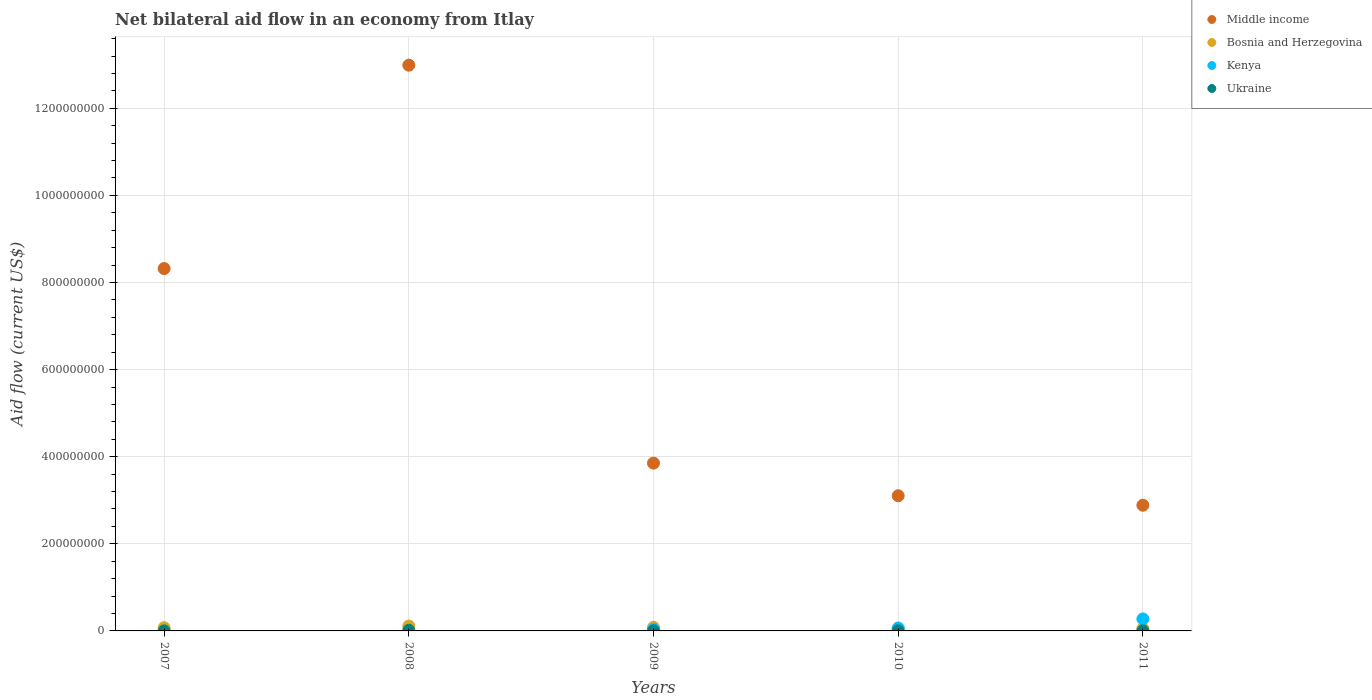Across all years, what is the maximum net bilateral aid flow in Ukraine?
Provide a short and direct response. 1.38e+06. Across all years, what is the minimum net bilateral aid flow in Middle income?
Your response must be concise. 2.89e+08. What is the total net bilateral aid flow in Middle income in the graph?
Offer a very short reply. 3.12e+09. What is the difference between the net bilateral aid flow in Middle income in 2008 and that in 2010?
Your answer should be very brief. 9.89e+08. What is the difference between the net bilateral aid flow in Kenya in 2011 and the net bilateral aid flow in Ukraine in 2007?
Offer a very short reply. 2.74e+07. What is the average net bilateral aid flow in Kenya per year?
Ensure brevity in your answer.  7.44e+06. In the year 2009, what is the difference between the net bilateral aid flow in Kenya and net bilateral aid flow in Ukraine?
Give a very brief answer. 2.78e+06. In how many years, is the net bilateral aid flow in Kenya greater than 1200000000 US$?
Your answer should be compact. 0. What is the ratio of the net bilateral aid flow in Ukraine in 2007 to that in 2008?
Provide a succinct answer. 0.07. What is the difference between the highest and the second highest net bilateral aid flow in Bosnia and Herzegovina?
Give a very brief answer. 3.05e+06. What is the difference between the highest and the lowest net bilateral aid flow in Kenya?
Offer a very short reply. 2.75e+07. In how many years, is the net bilateral aid flow in Ukraine greater than the average net bilateral aid flow in Ukraine taken over all years?
Provide a succinct answer. 1. Is the sum of the net bilateral aid flow in Bosnia and Herzegovina in 2009 and 2011 greater than the maximum net bilateral aid flow in Ukraine across all years?
Provide a succinct answer. Yes. Is it the case that in every year, the sum of the net bilateral aid flow in Ukraine and net bilateral aid flow in Kenya  is greater than the net bilateral aid flow in Bosnia and Herzegovina?
Offer a very short reply. No. Is the net bilateral aid flow in Middle income strictly greater than the net bilateral aid flow in Kenya over the years?
Ensure brevity in your answer.  Yes. Is the net bilateral aid flow in Ukraine strictly less than the net bilateral aid flow in Kenya over the years?
Offer a very short reply. No. Does the graph contain grids?
Your answer should be compact. Yes. How many legend labels are there?
Make the answer very short. 4. How are the legend labels stacked?
Your response must be concise. Vertical. What is the title of the graph?
Offer a terse response. Net bilateral aid flow in an economy from Itlay. Does "Thailand" appear as one of the legend labels in the graph?
Give a very brief answer. No. What is the Aid flow (current US$) in Middle income in 2007?
Your response must be concise. 8.32e+08. What is the Aid flow (current US$) in Bosnia and Herzegovina in 2007?
Offer a very short reply. 7.40e+06. What is the Aid flow (current US$) in Kenya in 2007?
Provide a succinct answer. 0. What is the Aid flow (current US$) in Ukraine in 2007?
Keep it short and to the point. 1.00e+05. What is the Aid flow (current US$) in Middle income in 2008?
Your answer should be very brief. 1.30e+09. What is the Aid flow (current US$) of Bosnia and Herzegovina in 2008?
Give a very brief answer. 1.12e+07. What is the Aid flow (current US$) in Kenya in 2008?
Make the answer very short. 0. What is the Aid flow (current US$) in Ukraine in 2008?
Your answer should be compact. 1.38e+06. What is the Aid flow (current US$) in Middle income in 2009?
Your response must be concise. 3.85e+08. What is the Aid flow (current US$) of Bosnia and Herzegovina in 2009?
Make the answer very short. 8.16e+06. What is the Aid flow (current US$) in Kenya in 2009?
Your answer should be very brief. 2.96e+06. What is the Aid flow (current US$) of Middle income in 2010?
Give a very brief answer. 3.10e+08. What is the Aid flow (current US$) of Bosnia and Herzegovina in 2010?
Offer a very short reply. 4.92e+06. What is the Aid flow (current US$) of Kenya in 2010?
Keep it short and to the point. 6.69e+06. What is the Aid flow (current US$) of Middle income in 2011?
Keep it short and to the point. 2.89e+08. What is the Aid flow (current US$) of Bosnia and Herzegovina in 2011?
Offer a very short reply. 5.19e+06. What is the Aid flow (current US$) in Kenya in 2011?
Provide a succinct answer. 2.75e+07. Across all years, what is the maximum Aid flow (current US$) in Middle income?
Your answer should be very brief. 1.30e+09. Across all years, what is the maximum Aid flow (current US$) of Bosnia and Herzegovina?
Your response must be concise. 1.12e+07. Across all years, what is the maximum Aid flow (current US$) of Kenya?
Give a very brief answer. 2.75e+07. Across all years, what is the maximum Aid flow (current US$) in Ukraine?
Provide a short and direct response. 1.38e+06. Across all years, what is the minimum Aid flow (current US$) of Middle income?
Keep it short and to the point. 2.89e+08. Across all years, what is the minimum Aid flow (current US$) in Bosnia and Herzegovina?
Provide a short and direct response. 4.92e+06. Across all years, what is the minimum Aid flow (current US$) of Kenya?
Give a very brief answer. 0. What is the total Aid flow (current US$) of Middle income in the graph?
Your answer should be compact. 3.12e+09. What is the total Aid flow (current US$) of Bosnia and Herzegovina in the graph?
Your answer should be compact. 3.69e+07. What is the total Aid flow (current US$) of Kenya in the graph?
Offer a terse response. 3.72e+07. What is the total Aid flow (current US$) in Ukraine in the graph?
Provide a succinct answer. 2.26e+06. What is the difference between the Aid flow (current US$) of Middle income in 2007 and that in 2008?
Your answer should be compact. -4.67e+08. What is the difference between the Aid flow (current US$) in Bosnia and Herzegovina in 2007 and that in 2008?
Keep it short and to the point. -3.81e+06. What is the difference between the Aid flow (current US$) of Ukraine in 2007 and that in 2008?
Provide a succinct answer. -1.28e+06. What is the difference between the Aid flow (current US$) in Middle income in 2007 and that in 2009?
Provide a succinct answer. 4.47e+08. What is the difference between the Aid flow (current US$) in Bosnia and Herzegovina in 2007 and that in 2009?
Keep it short and to the point. -7.60e+05. What is the difference between the Aid flow (current US$) in Middle income in 2007 and that in 2010?
Offer a terse response. 5.22e+08. What is the difference between the Aid flow (current US$) in Bosnia and Herzegovina in 2007 and that in 2010?
Your response must be concise. 2.48e+06. What is the difference between the Aid flow (current US$) of Ukraine in 2007 and that in 2010?
Provide a short and direct response. -1.80e+05. What is the difference between the Aid flow (current US$) in Middle income in 2007 and that in 2011?
Ensure brevity in your answer.  5.43e+08. What is the difference between the Aid flow (current US$) of Bosnia and Herzegovina in 2007 and that in 2011?
Your answer should be very brief. 2.21e+06. What is the difference between the Aid flow (current US$) of Ukraine in 2007 and that in 2011?
Make the answer very short. -2.20e+05. What is the difference between the Aid flow (current US$) in Middle income in 2008 and that in 2009?
Your response must be concise. 9.14e+08. What is the difference between the Aid flow (current US$) of Bosnia and Herzegovina in 2008 and that in 2009?
Offer a terse response. 3.05e+06. What is the difference between the Aid flow (current US$) in Ukraine in 2008 and that in 2009?
Provide a short and direct response. 1.20e+06. What is the difference between the Aid flow (current US$) in Middle income in 2008 and that in 2010?
Your answer should be compact. 9.89e+08. What is the difference between the Aid flow (current US$) in Bosnia and Herzegovina in 2008 and that in 2010?
Offer a very short reply. 6.29e+06. What is the difference between the Aid flow (current US$) in Ukraine in 2008 and that in 2010?
Ensure brevity in your answer.  1.10e+06. What is the difference between the Aid flow (current US$) of Middle income in 2008 and that in 2011?
Your answer should be compact. 1.01e+09. What is the difference between the Aid flow (current US$) in Bosnia and Herzegovina in 2008 and that in 2011?
Ensure brevity in your answer.  6.02e+06. What is the difference between the Aid flow (current US$) of Ukraine in 2008 and that in 2011?
Make the answer very short. 1.06e+06. What is the difference between the Aid flow (current US$) in Middle income in 2009 and that in 2010?
Ensure brevity in your answer.  7.49e+07. What is the difference between the Aid flow (current US$) in Bosnia and Herzegovina in 2009 and that in 2010?
Offer a very short reply. 3.24e+06. What is the difference between the Aid flow (current US$) of Kenya in 2009 and that in 2010?
Provide a short and direct response. -3.73e+06. What is the difference between the Aid flow (current US$) of Ukraine in 2009 and that in 2010?
Provide a short and direct response. -1.00e+05. What is the difference between the Aid flow (current US$) of Middle income in 2009 and that in 2011?
Provide a short and direct response. 9.66e+07. What is the difference between the Aid flow (current US$) of Bosnia and Herzegovina in 2009 and that in 2011?
Ensure brevity in your answer.  2.97e+06. What is the difference between the Aid flow (current US$) in Kenya in 2009 and that in 2011?
Provide a succinct answer. -2.46e+07. What is the difference between the Aid flow (current US$) in Middle income in 2010 and that in 2011?
Keep it short and to the point. 2.17e+07. What is the difference between the Aid flow (current US$) of Kenya in 2010 and that in 2011?
Make the answer very short. -2.08e+07. What is the difference between the Aid flow (current US$) in Ukraine in 2010 and that in 2011?
Keep it short and to the point. -4.00e+04. What is the difference between the Aid flow (current US$) in Middle income in 2007 and the Aid flow (current US$) in Bosnia and Herzegovina in 2008?
Give a very brief answer. 8.21e+08. What is the difference between the Aid flow (current US$) in Middle income in 2007 and the Aid flow (current US$) in Ukraine in 2008?
Your answer should be compact. 8.31e+08. What is the difference between the Aid flow (current US$) in Bosnia and Herzegovina in 2007 and the Aid flow (current US$) in Ukraine in 2008?
Your answer should be very brief. 6.02e+06. What is the difference between the Aid flow (current US$) in Middle income in 2007 and the Aid flow (current US$) in Bosnia and Herzegovina in 2009?
Your response must be concise. 8.24e+08. What is the difference between the Aid flow (current US$) of Middle income in 2007 and the Aid flow (current US$) of Kenya in 2009?
Make the answer very short. 8.29e+08. What is the difference between the Aid flow (current US$) of Middle income in 2007 and the Aid flow (current US$) of Ukraine in 2009?
Provide a succinct answer. 8.32e+08. What is the difference between the Aid flow (current US$) of Bosnia and Herzegovina in 2007 and the Aid flow (current US$) of Kenya in 2009?
Your answer should be very brief. 4.44e+06. What is the difference between the Aid flow (current US$) in Bosnia and Herzegovina in 2007 and the Aid flow (current US$) in Ukraine in 2009?
Provide a short and direct response. 7.22e+06. What is the difference between the Aid flow (current US$) in Middle income in 2007 and the Aid flow (current US$) in Bosnia and Herzegovina in 2010?
Offer a terse response. 8.27e+08. What is the difference between the Aid flow (current US$) of Middle income in 2007 and the Aid flow (current US$) of Kenya in 2010?
Provide a succinct answer. 8.25e+08. What is the difference between the Aid flow (current US$) in Middle income in 2007 and the Aid flow (current US$) in Ukraine in 2010?
Your response must be concise. 8.32e+08. What is the difference between the Aid flow (current US$) of Bosnia and Herzegovina in 2007 and the Aid flow (current US$) of Kenya in 2010?
Offer a terse response. 7.10e+05. What is the difference between the Aid flow (current US$) in Bosnia and Herzegovina in 2007 and the Aid flow (current US$) in Ukraine in 2010?
Provide a short and direct response. 7.12e+06. What is the difference between the Aid flow (current US$) in Middle income in 2007 and the Aid flow (current US$) in Bosnia and Herzegovina in 2011?
Ensure brevity in your answer.  8.27e+08. What is the difference between the Aid flow (current US$) in Middle income in 2007 and the Aid flow (current US$) in Kenya in 2011?
Your answer should be very brief. 8.04e+08. What is the difference between the Aid flow (current US$) of Middle income in 2007 and the Aid flow (current US$) of Ukraine in 2011?
Ensure brevity in your answer.  8.32e+08. What is the difference between the Aid flow (current US$) in Bosnia and Herzegovina in 2007 and the Aid flow (current US$) in Kenya in 2011?
Offer a terse response. -2.01e+07. What is the difference between the Aid flow (current US$) in Bosnia and Herzegovina in 2007 and the Aid flow (current US$) in Ukraine in 2011?
Offer a very short reply. 7.08e+06. What is the difference between the Aid flow (current US$) of Middle income in 2008 and the Aid flow (current US$) of Bosnia and Herzegovina in 2009?
Offer a very short reply. 1.29e+09. What is the difference between the Aid flow (current US$) in Middle income in 2008 and the Aid flow (current US$) in Kenya in 2009?
Give a very brief answer. 1.30e+09. What is the difference between the Aid flow (current US$) of Middle income in 2008 and the Aid flow (current US$) of Ukraine in 2009?
Offer a very short reply. 1.30e+09. What is the difference between the Aid flow (current US$) in Bosnia and Herzegovina in 2008 and the Aid flow (current US$) in Kenya in 2009?
Ensure brevity in your answer.  8.25e+06. What is the difference between the Aid flow (current US$) of Bosnia and Herzegovina in 2008 and the Aid flow (current US$) of Ukraine in 2009?
Give a very brief answer. 1.10e+07. What is the difference between the Aid flow (current US$) of Middle income in 2008 and the Aid flow (current US$) of Bosnia and Herzegovina in 2010?
Your answer should be compact. 1.29e+09. What is the difference between the Aid flow (current US$) in Middle income in 2008 and the Aid flow (current US$) in Kenya in 2010?
Provide a succinct answer. 1.29e+09. What is the difference between the Aid flow (current US$) in Middle income in 2008 and the Aid flow (current US$) in Ukraine in 2010?
Ensure brevity in your answer.  1.30e+09. What is the difference between the Aid flow (current US$) of Bosnia and Herzegovina in 2008 and the Aid flow (current US$) of Kenya in 2010?
Your response must be concise. 4.52e+06. What is the difference between the Aid flow (current US$) in Bosnia and Herzegovina in 2008 and the Aid flow (current US$) in Ukraine in 2010?
Make the answer very short. 1.09e+07. What is the difference between the Aid flow (current US$) of Middle income in 2008 and the Aid flow (current US$) of Bosnia and Herzegovina in 2011?
Your answer should be compact. 1.29e+09. What is the difference between the Aid flow (current US$) in Middle income in 2008 and the Aid flow (current US$) in Kenya in 2011?
Provide a succinct answer. 1.27e+09. What is the difference between the Aid flow (current US$) in Middle income in 2008 and the Aid flow (current US$) in Ukraine in 2011?
Your response must be concise. 1.30e+09. What is the difference between the Aid flow (current US$) of Bosnia and Herzegovina in 2008 and the Aid flow (current US$) of Kenya in 2011?
Offer a very short reply. -1.63e+07. What is the difference between the Aid flow (current US$) of Bosnia and Herzegovina in 2008 and the Aid flow (current US$) of Ukraine in 2011?
Keep it short and to the point. 1.09e+07. What is the difference between the Aid flow (current US$) in Middle income in 2009 and the Aid flow (current US$) in Bosnia and Herzegovina in 2010?
Provide a short and direct response. 3.80e+08. What is the difference between the Aid flow (current US$) of Middle income in 2009 and the Aid flow (current US$) of Kenya in 2010?
Provide a succinct answer. 3.79e+08. What is the difference between the Aid flow (current US$) in Middle income in 2009 and the Aid flow (current US$) in Ukraine in 2010?
Your answer should be very brief. 3.85e+08. What is the difference between the Aid flow (current US$) of Bosnia and Herzegovina in 2009 and the Aid flow (current US$) of Kenya in 2010?
Offer a very short reply. 1.47e+06. What is the difference between the Aid flow (current US$) of Bosnia and Herzegovina in 2009 and the Aid flow (current US$) of Ukraine in 2010?
Ensure brevity in your answer.  7.88e+06. What is the difference between the Aid flow (current US$) of Kenya in 2009 and the Aid flow (current US$) of Ukraine in 2010?
Your answer should be very brief. 2.68e+06. What is the difference between the Aid flow (current US$) in Middle income in 2009 and the Aid flow (current US$) in Bosnia and Herzegovina in 2011?
Ensure brevity in your answer.  3.80e+08. What is the difference between the Aid flow (current US$) in Middle income in 2009 and the Aid flow (current US$) in Kenya in 2011?
Your answer should be very brief. 3.58e+08. What is the difference between the Aid flow (current US$) of Middle income in 2009 and the Aid flow (current US$) of Ukraine in 2011?
Ensure brevity in your answer.  3.85e+08. What is the difference between the Aid flow (current US$) of Bosnia and Herzegovina in 2009 and the Aid flow (current US$) of Kenya in 2011?
Provide a succinct answer. -1.94e+07. What is the difference between the Aid flow (current US$) of Bosnia and Herzegovina in 2009 and the Aid flow (current US$) of Ukraine in 2011?
Keep it short and to the point. 7.84e+06. What is the difference between the Aid flow (current US$) of Kenya in 2009 and the Aid flow (current US$) of Ukraine in 2011?
Your response must be concise. 2.64e+06. What is the difference between the Aid flow (current US$) in Middle income in 2010 and the Aid flow (current US$) in Bosnia and Herzegovina in 2011?
Provide a short and direct response. 3.05e+08. What is the difference between the Aid flow (current US$) of Middle income in 2010 and the Aid flow (current US$) of Kenya in 2011?
Keep it short and to the point. 2.83e+08. What is the difference between the Aid flow (current US$) in Middle income in 2010 and the Aid flow (current US$) in Ukraine in 2011?
Your answer should be very brief. 3.10e+08. What is the difference between the Aid flow (current US$) of Bosnia and Herzegovina in 2010 and the Aid flow (current US$) of Kenya in 2011?
Give a very brief answer. -2.26e+07. What is the difference between the Aid flow (current US$) of Bosnia and Herzegovina in 2010 and the Aid flow (current US$) of Ukraine in 2011?
Provide a succinct answer. 4.60e+06. What is the difference between the Aid flow (current US$) in Kenya in 2010 and the Aid flow (current US$) in Ukraine in 2011?
Give a very brief answer. 6.37e+06. What is the average Aid flow (current US$) in Middle income per year?
Offer a terse response. 6.23e+08. What is the average Aid flow (current US$) of Bosnia and Herzegovina per year?
Your answer should be compact. 7.38e+06. What is the average Aid flow (current US$) of Kenya per year?
Keep it short and to the point. 7.44e+06. What is the average Aid flow (current US$) in Ukraine per year?
Offer a terse response. 4.52e+05. In the year 2007, what is the difference between the Aid flow (current US$) in Middle income and Aid flow (current US$) in Bosnia and Herzegovina?
Your answer should be compact. 8.25e+08. In the year 2007, what is the difference between the Aid flow (current US$) in Middle income and Aid flow (current US$) in Ukraine?
Offer a very short reply. 8.32e+08. In the year 2007, what is the difference between the Aid flow (current US$) in Bosnia and Herzegovina and Aid flow (current US$) in Ukraine?
Provide a short and direct response. 7.30e+06. In the year 2008, what is the difference between the Aid flow (current US$) in Middle income and Aid flow (current US$) in Bosnia and Herzegovina?
Give a very brief answer. 1.29e+09. In the year 2008, what is the difference between the Aid flow (current US$) in Middle income and Aid flow (current US$) in Ukraine?
Offer a very short reply. 1.30e+09. In the year 2008, what is the difference between the Aid flow (current US$) in Bosnia and Herzegovina and Aid flow (current US$) in Ukraine?
Give a very brief answer. 9.83e+06. In the year 2009, what is the difference between the Aid flow (current US$) of Middle income and Aid flow (current US$) of Bosnia and Herzegovina?
Your response must be concise. 3.77e+08. In the year 2009, what is the difference between the Aid flow (current US$) of Middle income and Aid flow (current US$) of Kenya?
Give a very brief answer. 3.82e+08. In the year 2009, what is the difference between the Aid flow (current US$) in Middle income and Aid flow (current US$) in Ukraine?
Keep it short and to the point. 3.85e+08. In the year 2009, what is the difference between the Aid flow (current US$) of Bosnia and Herzegovina and Aid flow (current US$) of Kenya?
Provide a short and direct response. 5.20e+06. In the year 2009, what is the difference between the Aid flow (current US$) in Bosnia and Herzegovina and Aid flow (current US$) in Ukraine?
Your answer should be compact. 7.98e+06. In the year 2009, what is the difference between the Aid flow (current US$) of Kenya and Aid flow (current US$) of Ukraine?
Give a very brief answer. 2.78e+06. In the year 2010, what is the difference between the Aid flow (current US$) of Middle income and Aid flow (current US$) of Bosnia and Herzegovina?
Give a very brief answer. 3.05e+08. In the year 2010, what is the difference between the Aid flow (current US$) in Middle income and Aid flow (current US$) in Kenya?
Ensure brevity in your answer.  3.04e+08. In the year 2010, what is the difference between the Aid flow (current US$) in Middle income and Aid flow (current US$) in Ukraine?
Provide a succinct answer. 3.10e+08. In the year 2010, what is the difference between the Aid flow (current US$) in Bosnia and Herzegovina and Aid flow (current US$) in Kenya?
Ensure brevity in your answer.  -1.77e+06. In the year 2010, what is the difference between the Aid flow (current US$) in Bosnia and Herzegovina and Aid flow (current US$) in Ukraine?
Make the answer very short. 4.64e+06. In the year 2010, what is the difference between the Aid flow (current US$) in Kenya and Aid flow (current US$) in Ukraine?
Provide a short and direct response. 6.41e+06. In the year 2011, what is the difference between the Aid flow (current US$) of Middle income and Aid flow (current US$) of Bosnia and Herzegovina?
Provide a short and direct response. 2.83e+08. In the year 2011, what is the difference between the Aid flow (current US$) in Middle income and Aid flow (current US$) in Kenya?
Your answer should be very brief. 2.61e+08. In the year 2011, what is the difference between the Aid flow (current US$) in Middle income and Aid flow (current US$) in Ukraine?
Your answer should be compact. 2.88e+08. In the year 2011, what is the difference between the Aid flow (current US$) of Bosnia and Herzegovina and Aid flow (current US$) of Kenya?
Provide a short and direct response. -2.24e+07. In the year 2011, what is the difference between the Aid flow (current US$) of Bosnia and Herzegovina and Aid flow (current US$) of Ukraine?
Provide a short and direct response. 4.87e+06. In the year 2011, what is the difference between the Aid flow (current US$) of Kenya and Aid flow (current US$) of Ukraine?
Provide a short and direct response. 2.72e+07. What is the ratio of the Aid flow (current US$) of Middle income in 2007 to that in 2008?
Keep it short and to the point. 0.64. What is the ratio of the Aid flow (current US$) in Bosnia and Herzegovina in 2007 to that in 2008?
Keep it short and to the point. 0.66. What is the ratio of the Aid flow (current US$) of Ukraine in 2007 to that in 2008?
Offer a terse response. 0.07. What is the ratio of the Aid flow (current US$) of Middle income in 2007 to that in 2009?
Ensure brevity in your answer.  2.16. What is the ratio of the Aid flow (current US$) of Bosnia and Herzegovina in 2007 to that in 2009?
Give a very brief answer. 0.91. What is the ratio of the Aid flow (current US$) in Ukraine in 2007 to that in 2009?
Your answer should be very brief. 0.56. What is the ratio of the Aid flow (current US$) of Middle income in 2007 to that in 2010?
Your answer should be compact. 2.68. What is the ratio of the Aid flow (current US$) of Bosnia and Herzegovina in 2007 to that in 2010?
Keep it short and to the point. 1.5. What is the ratio of the Aid flow (current US$) in Ukraine in 2007 to that in 2010?
Make the answer very short. 0.36. What is the ratio of the Aid flow (current US$) of Middle income in 2007 to that in 2011?
Ensure brevity in your answer.  2.88. What is the ratio of the Aid flow (current US$) of Bosnia and Herzegovina in 2007 to that in 2011?
Offer a very short reply. 1.43. What is the ratio of the Aid flow (current US$) in Ukraine in 2007 to that in 2011?
Provide a short and direct response. 0.31. What is the ratio of the Aid flow (current US$) in Middle income in 2008 to that in 2009?
Your answer should be very brief. 3.37. What is the ratio of the Aid flow (current US$) in Bosnia and Herzegovina in 2008 to that in 2009?
Offer a very short reply. 1.37. What is the ratio of the Aid flow (current US$) in Ukraine in 2008 to that in 2009?
Ensure brevity in your answer.  7.67. What is the ratio of the Aid flow (current US$) of Middle income in 2008 to that in 2010?
Ensure brevity in your answer.  4.19. What is the ratio of the Aid flow (current US$) of Bosnia and Herzegovina in 2008 to that in 2010?
Give a very brief answer. 2.28. What is the ratio of the Aid flow (current US$) in Ukraine in 2008 to that in 2010?
Your response must be concise. 4.93. What is the ratio of the Aid flow (current US$) in Middle income in 2008 to that in 2011?
Your response must be concise. 4.5. What is the ratio of the Aid flow (current US$) in Bosnia and Herzegovina in 2008 to that in 2011?
Your answer should be compact. 2.16. What is the ratio of the Aid flow (current US$) in Ukraine in 2008 to that in 2011?
Your answer should be very brief. 4.31. What is the ratio of the Aid flow (current US$) in Middle income in 2009 to that in 2010?
Offer a very short reply. 1.24. What is the ratio of the Aid flow (current US$) in Bosnia and Herzegovina in 2009 to that in 2010?
Your answer should be very brief. 1.66. What is the ratio of the Aid flow (current US$) of Kenya in 2009 to that in 2010?
Ensure brevity in your answer.  0.44. What is the ratio of the Aid flow (current US$) of Ukraine in 2009 to that in 2010?
Provide a succinct answer. 0.64. What is the ratio of the Aid flow (current US$) in Middle income in 2009 to that in 2011?
Your answer should be very brief. 1.33. What is the ratio of the Aid flow (current US$) in Bosnia and Herzegovina in 2009 to that in 2011?
Keep it short and to the point. 1.57. What is the ratio of the Aid flow (current US$) of Kenya in 2009 to that in 2011?
Your response must be concise. 0.11. What is the ratio of the Aid flow (current US$) of Ukraine in 2009 to that in 2011?
Your answer should be compact. 0.56. What is the ratio of the Aid flow (current US$) in Middle income in 2010 to that in 2011?
Offer a very short reply. 1.08. What is the ratio of the Aid flow (current US$) of Bosnia and Herzegovina in 2010 to that in 2011?
Give a very brief answer. 0.95. What is the ratio of the Aid flow (current US$) of Kenya in 2010 to that in 2011?
Provide a short and direct response. 0.24. What is the difference between the highest and the second highest Aid flow (current US$) of Middle income?
Provide a succinct answer. 4.67e+08. What is the difference between the highest and the second highest Aid flow (current US$) in Bosnia and Herzegovina?
Offer a terse response. 3.05e+06. What is the difference between the highest and the second highest Aid flow (current US$) in Kenya?
Make the answer very short. 2.08e+07. What is the difference between the highest and the second highest Aid flow (current US$) in Ukraine?
Your response must be concise. 1.06e+06. What is the difference between the highest and the lowest Aid flow (current US$) in Middle income?
Provide a succinct answer. 1.01e+09. What is the difference between the highest and the lowest Aid flow (current US$) in Bosnia and Herzegovina?
Offer a very short reply. 6.29e+06. What is the difference between the highest and the lowest Aid flow (current US$) of Kenya?
Ensure brevity in your answer.  2.75e+07. What is the difference between the highest and the lowest Aid flow (current US$) of Ukraine?
Your answer should be compact. 1.28e+06. 